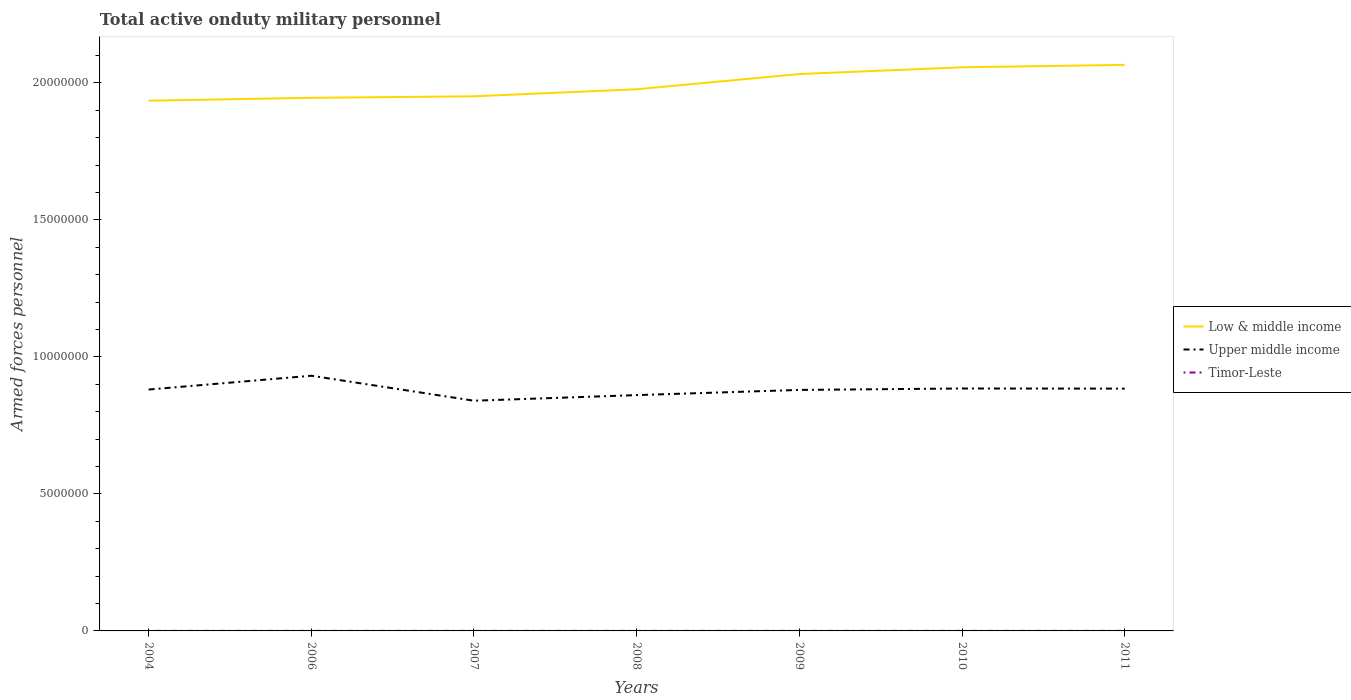Does the line corresponding to Timor-Leste intersect with the line corresponding to Low & middle income?
Give a very brief answer. No. Across all years, what is the maximum number of armed forces personnel in Timor-Leste?
Ensure brevity in your answer.  1000. What is the total number of armed forces personnel in Timor-Leste in the graph?
Ensure brevity in your answer.  -332. What is the difference between the highest and the second highest number of armed forces personnel in Timor-Leste?
Your response must be concise. 332. What is the difference between the highest and the lowest number of armed forces personnel in Upper middle income?
Provide a short and direct response. 4. Is the number of armed forces personnel in Upper middle income strictly greater than the number of armed forces personnel in Low & middle income over the years?
Make the answer very short. Yes. Are the values on the major ticks of Y-axis written in scientific E-notation?
Keep it short and to the point. No. Where does the legend appear in the graph?
Provide a short and direct response. Center right. How many legend labels are there?
Provide a succinct answer. 3. What is the title of the graph?
Keep it short and to the point. Total active onduty military personnel. What is the label or title of the X-axis?
Make the answer very short. Years. What is the label or title of the Y-axis?
Offer a very short reply. Armed forces personnel. What is the Armed forces personnel in Low & middle income in 2004?
Offer a very short reply. 1.94e+07. What is the Armed forces personnel of Upper middle income in 2004?
Provide a short and direct response. 8.81e+06. What is the Armed forces personnel in Timor-Leste in 2004?
Make the answer very short. 1000. What is the Armed forces personnel of Low & middle income in 2006?
Provide a succinct answer. 1.95e+07. What is the Armed forces personnel in Upper middle income in 2006?
Provide a short and direct response. 9.31e+06. What is the Armed forces personnel in Timor-Leste in 2006?
Your answer should be very brief. 1000. What is the Armed forces personnel in Low & middle income in 2007?
Keep it short and to the point. 1.95e+07. What is the Armed forces personnel of Upper middle income in 2007?
Offer a very short reply. 8.40e+06. What is the Armed forces personnel in Timor-Leste in 2007?
Your answer should be compact. 1000. What is the Armed forces personnel of Low & middle income in 2008?
Provide a succinct answer. 1.98e+07. What is the Armed forces personnel in Upper middle income in 2008?
Keep it short and to the point. 8.61e+06. What is the Armed forces personnel of Low & middle income in 2009?
Your answer should be compact. 2.03e+07. What is the Armed forces personnel of Upper middle income in 2009?
Offer a terse response. 8.80e+06. What is the Armed forces personnel of Timor-Leste in 2009?
Provide a succinct answer. 1332. What is the Armed forces personnel in Low & middle income in 2010?
Your answer should be very brief. 2.06e+07. What is the Armed forces personnel in Upper middle income in 2010?
Make the answer very short. 8.85e+06. What is the Armed forces personnel in Timor-Leste in 2010?
Provide a short and direct response. 1332. What is the Armed forces personnel in Low & middle income in 2011?
Give a very brief answer. 2.07e+07. What is the Armed forces personnel in Upper middle income in 2011?
Your answer should be compact. 8.84e+06. What is the Armed forces personnel of Timor-Leste in 2011?
Offer a terse response. 1330. Across all years, what is the maximum Armed forces personnel of Low & middle income?
Keep it short and to the point. 2.07e+07. Across all years, what is the maximum Armed forces personnel in Upper middle income?
Your answer should be very brief. 9.31e+06. Across all years, what is the maximum Armed forces personnel of Timor-Leste?
Keep it short and to the point. 1332. Across all years, what is the minimum Armed forces personnel of Low & middle income?
Provide a succinct answer. 1.94e+07. Across all years, what is the minimum Armed forces personnel in Upper middle income?
Make the answer very short. 8.40e+06. Across all years, what is the minimum Armed forces personnel of Timor-Leste?
Offer a very short reply. 1000. What is the total Armed forces personnel in Low & middle income in the graph?
Provide a succinct answer. 1.40e+08. What is the total Armed forces personnel in Upper middle income in the graph?
Give a very brief answer. 6.16e+07. What is the total Armed forces personnel in Timor-Leste in the graph?
Your answer should be compact. 7994. What is the difference between the Armed forces personnel of Low & middle income in 2004 and that in 2006?
Offer a very short reply. -1.04e+05. What is the difference between the Armed forces personnel in Upper middle income in 2004 and that in 2006?
Make the answer very short. -5.04e+05. What is the difference between the Armed forces personnel in Low & middle income in 2004 and that in 2007?
Ensure brevity in your answer.  -1.60e+05. What is the difference between the Armed forces personnel of Upper middle income in 2004 and that in 2007?
Your answer should be very brief. 4.08e+05. What is the difference between the Armed forces personnel of Timor-Leste in 2004 and that in 2007?
Provide a succinct answer. 0. What is the difference between the Armed forces personnel of Low & middle income in 2004 and that in 2008?
Offer a very short reply. -4.17e+05. What is the difference between the Armed forces personnel of Upper middle income in 2004 and that in 2008?
Your answer should be compact. 2.03e+05. What is the difference between the Armed forces personnel in Low & middle income in 2004 and that in 2009?
Give a very brief answer. -9.72e+05. What is the difference between the Armed forces personnel in Upper middle income in 2004 and that in 2009?
Offer a terse response. 1.35e+04. What is the difference between the Armed forces personnel in Timor-Leste in 2004 and that in 2009?
Keep it short and to the point. -332. What is the difference between the Armed forces personnel of Low & middle income in 2004 and that in 2010?
Give a very brief answer. -1.22e+06. What is the difference between the Armed forces personnel in Upper middle income in 2004 and that in 2010?
Offer a terse response. -3.85e+04. What is the difference between the Armed forces personnel of Timor-Leste in 2004 and that in 2010?
Your answer should be very brief. -332. What is the difference between the Armed forces personnel of Low & middle income in 2004 and that in 2011?
Provide a short and direct response. -1.31e+06. What is the difference between the Armed forces personnel in Upper middle income in 2004 and that in 2011?
Your answer should be very brief. -3.43e+04. What is the difference between the Armed forces personnel in Timor-Leste in 2004 and that in 2011?
Keep it short and to the point. -330. What is the difference between the Armed forces personnel of Low & middle income in 2006 and that in 2007?
Offer a terse response. -5.58e+04. What is the difference between the Armed forces personnel of Upper middle income in 2006 and that in 2007?
Offer a very short reply. 9.12e+05. What is the difference between the Armed forces personnel in Low & middle income in 2006 and that in 2008?
Provide a short and direct response. -3.13e+05. What is the difference between the Armed forces personnel of Upper middle income in 2006 and that in 2008?
Offer a terse response. 7.07e+05. What is the difference between the Armed forces personnel of Low & middle income in 2006 and that in 2009?
Provide a succinct answer. -8.68e+05. What is the difference between the Armed forces personnel in Upper middle income in 2006 and that in 2009?
Ensure brevity in your answer.  5.18e+05. What is the difference between the Armed forces personnel in Timor-Leste in 2006 and that in 2009?
Make the answer very short. -332. What is the difference between the Armed forces personnel in Low & middle income in 2006 and that in 2010?
Provide a short and direct response. -1.11e+06. What is the difference between the Armed forces personnel in Upper middle income in 2006 and that in 2010?
Provide a succinct answer. 4.66e+05. What is the difference between the Armed forces personnel of Timor-Leste in 2006 and that in 2010?
Ensure brevity in your answer.  -332. What is the difference between the Armed forces personnel of Low & middle income in 2006 and that in 2011?
Keep it short and to the point. -1.20e+06. What is the difference between the Armed forces personnel in Upper middle income in 2006 and that in 2011?
Offer a very short reply. 4.70e+05. What is the difference between the Armed forces personnel of Timor-Leste in 2006 and that in 2011?
Your answer should be very brief. -330. What is the difference between the Armed forces personnel in Low & middle income in 2007 and that in 2008?
Offer a very short reply. -2.57e+05. What is the difference between the Armed forces personnel in Upper middle income in 2007 and that in 2008?
Offer a very short reply. -2.05e+05. What is the difference between the Armed forces personnel in Timor-Leste in 2007 and that in 2008?
Offer a terse response. 0. What is the difference between the Armed forces personnel of Low & middle income in 2007 and that in 2009?
Give a very brief answer. -8.12e+05. What is the difference between the Armed forces personnel of Upper middle income in 2007 and that in 2009?
Your response must be concise. -3.94e+05. What is the difference between the Armed forces personnel in Timor-Leste in 2007 and that in 2009?
Keep it short and to the point. -332. What is the difference between the Armed forces personnel in Low & middle income in 2007 and that in 2010?
Your answer should be very brief. -1.06e+06. What is the difference between the Armed forces personnel of Upper middle income in 2007 and that in 2010?
Provide a short and direct response. -4.46e+05. What is the difference between the Armed forces personnel of Timor-Leste in 2007 and that in 2010?
Provide a short and direct response. -332. What is the difference between the Armed forces personnel in Low & middle income in 2007 and that in 2011?
Your answer should be very brief. -1.15e+06. What is the difference between the Armed forces personnel of Upper middle income in 2007 and that in 2011?
Offer a terse response. -4.42e+05. What is the difference between the Armed forces personnel in Timor-Leste in 2007 and that in 2011?
Your answer should be compact. -330. What is the difference between the Armed forces personnel in Low & middle income in 2008 and that in 2009?
Keep it short and to the point. -5.55e+05. What is the difference between the Armed forces personnel in Upper middle income in 2008 and that in 2009?
Give a very brief answer. -1.89e+05. What is the difference between the Armed forces personnel of Timor-Leste in 2008 and that in 2009?
Your response must be concise. -332. What is the difference between the Armed forces personnel in Low & middle income in 2008 and that in 2010?
Your response must be concise. -8.02e+05. What is the difference between the Armed forces personnel in Upper middle income in 2008 and that in 2010?
Provide a short and direct response. -2.41e+05. What is the difference between the Armed forces personnel in Timor-Leste in 2008 and that in 2010?
Make the answer very short. -332. What is the difference between the Armed forces personnel of Low & middle income in 2008 and that in 2011?
Keep it short and to the point. -8.90e+05. What is the difference between the Armed forces personnel in Upper middle income in 2008 and that in 2011?
Make the answer very short. -2.37e+05. What is the difference between the Armed forces personnel of Timor-Leste in 2008 and that in 2011?
Keep it short and to the point. -330. What is the difference between the Armed forces personnel of Low & middle income in 2009 and that in 2010?
Ensure brevity in your answer.  -2.46e+05. What is the difference between the Armed forces personnel in Upper middle income in 2009 and that in 2010?
Make the answer very short. -5.20e+04. What is the difference between the Armed forces personnel in Low & middle income in 2009 and that in 2011?
Your answer should be very brief. -3.35e+05. What is the difference between the Armed forces personnel in Upper middle income in 2009 and that in 2011?
Give a very brief answer. -4.79e+04. What is the difference between the Armed forces personnel in Low & middle income in 2010 and that in 2011?
Keep it short and to the point. -8.85e+04. What is the difference between the Armed forces personnel in Upper middle income in 2010 and that in 2011?
Provide a short and direct response. 4131. What is the difference between the Armed forces personnel in Timor-Leste in 2010 and that in 2011?
Offer a very short reply. 2. What is the difference between the Armed forces personnel in Low & middle income in 2004 and the Armed forces personnel in Upper middle income in 2006?
Your response must be concise. 1.00e+07. What is the difference between the Armed forces personnel in Low & middle income in 2004 and the Armed forces personnel in Timor-Leste in 2006?
Your answer should be very brief. 1.94e+07. What is the difference between the Armed forces personnel of Upper middle income in 2004 and the Armed forces personnel of Timor-Leste in 2006?
Your response must be concise. 8.81e+06. What is the difference between the Armed forces personnel of Low & middle income in 2004 and the Armed forces personnel of Upper middle income in 2007?
Your response must be concise. 1.10e+07. What is the difference between the Armed forces personnel in Low & middle income in 2004 and the Armed forces personnel in Timor-Leste in 2007?
Your answer should be very brief. 1.94e+07. What is the difference between the Armed forces personnel in Upper middle income in 2004 and the Armed forces personnel in Timor-Leste in 2007?
Keep it short and to the point. 8.81e+06. What is the difference between the Armed forces personnel in Low & middle income in 2004 and the Armed forces personnel in Upper middle income in 2008?
Make the answer very short. 1.07e+07. What is the difference between the Armed forces personnel of Low & middle income in 2004 and the Armed forces personnel of Timor-Leste in 2008?
Ensure brevity in your answer.  1.94e+07. What is the difference between the Armed forces personnel of Upper middle income in 2004 and the Armed forces personnel of Timor-Leste in 2008?
Offer a very short reply. 8.81e+06. What is the difference between the Armed forces personnel in Low & middle income in 2004 and the Armed forces personnel in Upper middle income in 2009?
Give a very brief answer. 1.06e+07. What is the difference between the Armed forces personnel in Low & middle income in 2004 and the Armed forces personnel in Timor-Leste in 2009?
Provide a succinct answer. 1.94e+07. What is the difference between the Armed forces personnel of Upper middle income in 2004 and the Armed forces personnel of Timor-Leste in 2009?
Ensure brevity in your answer.  8.81e+06. What is the difference between the Armed forces personnel in Low & middle income in 2004 and the Armed forces personnel in Upper middle income in 2010?
Provide a short and direct response. 1.05e+07. What is the difference between the Armed forces personnel in Low & middle income in 2004 and the Armed forces personnel in Timor-Leste in 2010?
Your answer should be compact. 1.94e+07. What is the difference between the Armed forces personnel in Upper middle income in 2004 and the Armed forces personnel in Timor-Leste in 2010?
Offer a very short reply. 8.81e+06. What is the difference between the Armed forces personnel of Low & middle income in 2004 and the Armed forces personnel of Upper middle income in 2011?
Give a very brief answer. 1.05e+07. What is the difference between the Armed forces personnel of Low & middle income in 2004 and the Armed forces personnel of Timor-Leste in 2011?
Provide a succinct answer. 1.94e+07. What is the difference between the Armed forces personnel in Upper middle income in 2004 and the Armed forces personnel in Timor-Leste in 2011?
Keep it short and to the point. 8.81e+06. What is the difference between the Armed forces personnel in Low & middle income in 2006 and the Armed forces personnel in Upper middle income in 2007?
Keep it short and to the point. 1.11e+07. What is the difference between the Armed forces personnel of Low & middle income in 2006 and the Armed forces personnel of Timor-Leste in 2007?
Keep it short and to the point. 1.95e+07. What is the difference between the Armed forces personnel in Upper middle income in 2006 and the Armed forces personnel in Timor-Leste in 2007?
Make the answer very short. 9.31e+06. What is the difference between the Armed forces personnel in Low & middle income in 2006 and the Armed forces personnel in Upper middle income in 2008?
Keep it short and to the point. 1.09e+07. What is the difference between the Armed forces personnel in Low & middle income in 2006 and the Armed forces personnel in Timor-Leste in 2008?
Give a very brief answer. 1.95e+07. What is the difference between the Armed forces personnel in Upper middle income in 2006 and the Armed forces personnel in Timor-Leste in 2008?
Your response must be concise. 9.31e+06. What is the difference between the Armed forces personnel of Low & middle income in 2006 and the Armed forces personnel of Upper middle income in 2009?
Offer a very short reply. 1.07e+07. What is the difference between the Armed forces personnel in Low & middle income in 2006 and the Armed forces personnel in Timor-Leste in 2009?
Make the answer very short. 1.95e+07. What is the difference between the Armed forces personnel of Upper middle income in 2006 and the Armed forces personnel of Timor-Leste in 2009?
Make the answer very short. 9.31e+06. What is the difference between the Armed forces personnel of Low & middle income in 2006 and the Armed forces personnel of Upper middle income in 2010?
Your response must be concise. 1.06e+07. What is the difference between the Armed forces personnel of Low & middle income in 2006 and the Armed forces personnel of Timor-Leste in 2010?
Your answer should be compact. 1.95e+07. What is the difference between the Armed forces personnel of Upper middle income in 2006 and the Armed forces personnel of Timor-Leste in 2010?
Your answer should be very brief. 9.31e+06. What is the difference between the Armed forces personnel of Low & middle income in 2006 and the Armed forces personnel of Upper middle income in 2011?
Your answer should be very brief. 1.06e+07. What is the difference between the Armed forces personnel in Low & middle income in 2006 and the Armed forces personnel in Timor-Leste in 2011?
Make the answer very short. 1.95e+07. What is the difference between the Armed forces personnel of Upper middle income in 2006 and the Armed forces personnel of Timor-Leste in 2011?
Keep it short and to the point. 9.31e+06. What is the difference between the Armed forces personnel in Low & middle income in 2007 and the Armed forces personnel in Upper middle income in 2008?
Your response must be concise. 1.09e+07. What is the difference between the Armed forces personnel in Low & middle income in 2007 and the Armed forces personnel in Timor-Leste in 2008?
Ensure brevity in your answer.  1.95e+07. What is the difference between the Armed forces personnel in Upper middle income in 2007 and the Armed forces personnel in Timor-Leste in 2008?
Provide a succinct answer. 8.40e+06. What is the difference between the Armed forces personnel of Low & middle income in 2007 and the Armed forces personnel of Upper middle income in 2009?
Ensure brevity in your answer.  1.07e+07. What is the difference between the Armed forces personnel in Low & middle income in 2007 and the Armed forces personnel in Timor-Leste in 2009?
Give a very brief answer. 1.95e+07. What is the difference between the Armed forces personnel in Upper middle income in 2007 and the Armed forces personnel in Timor-Leste in 2009?
Your answer should be compact. 8.40e+06. What is the difference between the Armed forces personnel in Low & middle income in 2007 and the Armed forces personnel in Upper middle income in 2010?
Give a very brief answer. 1.07e+07. What is the difference between the Armed forces personnel of Low & middle income in 2007 and the Armed forces personnel of Timor-Leste in 2010?
Make the answer very short. 1.95e+07. What is the difference between the Armed forces personnel of Upper middle income in 2007 and the Armed forces personnel of Timor-Leste in 2010?
Your response must be concise. 8.40e+06. What is the difference between the Armed forces personnel of Low & middle income in 2007 and the Armed forces personnel of Upper middle income in 2011?
Your answer should be compact. 1.07e+07. What is the difference between the Armed forces personnel in Low & middle income in 2007 and the Armed forces personnel in Timor-Leste in 2011?
Offer a terse response. 1.95e+07. What is the difference between the Armed forces personnel in Upper middle income in 2007 and the Armed forces personnel in Timor-Leste in 2011?
Offer a terse response. 8.40e+06. What is the difference between the Armed forces personnel of Low & middle income in 2008 and the Armed forces personnel of Upper middle income in 2009?
Make the answer very short. 1.10e+07. What is the difference between the Armed forces personnel of Low & middle income in 2008 and the Armed forces personnel of Timor-Leste in 2009?
Offer a very short reply. 1.98e+07. What is the difference between the Armed forces personnel in Upper middle income in 2008 and the Armed forces personnel in Timor-Leste in 2009?
Provide a short and direct response. 8.61e+06. What is the difference between the Armed forces personnel of Low & middle income in 2008 and the Armed forces personnel of Upper middle income in 2010?
Offer a terse response. 1.09e+07. What is the difference between the Armed forces personnel in Low & middle income in 2008 and the Armed forces personnel in Timor-Leste in 2010?
Keep it short and to the point. 1.98e+07. What is the difference between the Armed forces personnel in Upper middle income in 2008 and the Armed forces personnel in Timor-Leste in 2010?
Keep it short and to the point. 8.61e+06. What is the difference between the Armed forces personnel of Low & middle income in 2008 and the Armed forces personnel of Upper middle income in 2011?
Your answer should be very brief. 1.09e+07. What is the difference between the Armed forces personnel in Low & middle income in 2008 and the Armed forces personnel in Timor-Leste in 2011?
Keep it short and to the point. 1.98e+07. What is the difference between the Armed forces personnel in Upper middle income in 2008 and the Armed forces personnel in Timor-Leste in 2011?
Your response must be concise. 8.61e+06. What is the difference between the Armed forces personnel of Low & middle income in 2009 and the Armed forces personnel of Upper middle income in 2010?
Keep it short and to the point. 1.15e+07. What is the difference between the Armed forces personnel in Low & middle income in 2009 and the Armed forces personnel in Timor-Leste in 2010?
Your answer should be very brief. 2.03e+07. What is the difference between the Armed forces personnel of Upper middle income in 2009 and the Armed forces personnel of Timor-Leste in 2010?
Provide a short and direct response. 8.79e+06. What is the difference between the Armed forces personnel in Low & middle income in 2009 and the Armed forces personnel in Upper middle income in 2011?
Ensure brevity in your answer.  1.15e+07. What is the difference between the Armed forces personnel in Low & middle income in 2009 and the Armed forces personnel in Timor-Leste in 2011?
Provide a succinct answer. 2.03e+07. What is the difference between the Armed forces personnel of Upper middle income in 2009 and the Armed forces personnel of Timor-Leste in 2011?
Offer a terse response. 8.79e+06. What is the difference between the Armed forces personnel in Low & middle income in 2010 and the Armed forces personnel in Upper middle income in 2011?
Provide a short and direct response. 1.17e+07. What is the difference between the Armed forces personnel in Low & middle income in 2010 and the Armed forces personnel in Timor-Leste in 2011?
Keep it short and to the point. 2.06e+07. What is the difference between the Armed forces personnel in Upper middle income in 2010 and the Armed forces personnel in Timor-Leste in 2011?
Offer a very short reply. 8.85e+06. What is the average Armed forces personnel in Low & middle income per year?
Provide a succinct answer. 1.99e+07. What is the average Armed forces personnel in Upper middle income per year?
Ensure brevity in your answer.  8.80e+06. What is the average Armed forces personnel in Timor-Leste per year?
Make the answer very short. 1142. In the year 2004, what is the difference between the Armed forces personnel in Low & middle income and Armed forces personnel in Upper middle income?
Your answer should be very brief. 1.05e+07. In the year 2004, what is the difference between the Armed forces personnel of Low & middle income and Armed forces personnel of Timor-Leste?
Give a very brief answer. 1.94e+07. In the year 2004, what is the difference between the Armed forces personnel in Upper middle income and Armed forces personnel in Timor-Leste?
Your response must be concise. 8.81e+06. In the year 2006, what is the difference between the Armed forces personnel in Low & middle income and Armed forces personnel in Upper middle income?
Your response must be concise. 1.01e+07. In the year 2006, what is the difference between the Armed forces personnel of Low & middle income and Armed forces personnel of Timor-Leste?
Your response must be concise. 1.95e+07. In the year 2006, what is the difference between the Armed forces personnel in Upper middle income and Armed forces personnel in Timor-Leste?
Keep it short and to the point. 9.31e+06. In the year 2007, what is the difference between the Armed forces personnel in Low & middle income and Armed forces personnel in Upper middle income?
Provide a succinct answer. 1.11e+07. In the year 2007, what is the difference between the Armed forces personnel of Low & middle income and Armed forces personnel of Timor-Leste?
Provide a succinct answer. 1.95e+07. In the year 2007, what is the difference between the Armed forces personnel in Upper middle income and Armed forces personnel in Timor-Leste?
Provide a short and direct response. 8.40e+06. In the year 2008, what is the difference between the Armed forces personnel of Low & middle income and Armed forces personnel of Upper middle income?
Provide a succinct answer. 1.12e+07. In the year 2008, what is the difference between the Armed forces personnel in Low & middle income and Armed forces personnel in Timor-Leste?
Make the answer very short. 1.98e+07. In the year 2008, what is the difference between the Armed forces personnel in Upper middle income and Armed forces personnel in Timor-Leste?
Keep it short and to the point. 8.61e+06. In the year 2009, what is the difference between the Armed forces personnel in Low & middle income and Armed forces personnel in Upper middle income?
Your answer should be very brief. 1.15e+07. In the year 2009, what is the difference between the Armed forces personnel of Low & middle income and Armed forces personnel of Timor-Leste?
Offer a very short reply. 2.03e+07. In the year 2009, what is the difference between the Armed forces personnel of Upper middle income and Armed forces personnel of Timor-Leste?
Keep it short and to the point. 8.79e+06. In the year 2010, what is the difference between the Armed forces personnel of Low & middle income and Armed forces personnel of Upper middle income?
Keep it short and to the point. 1.17e+07. In the year 2010, what is the difference between the Armed forces personnel in Low & middle income and Armed forces personnel in Timor-Leste?
Your answer should be compact. 2.06e+07. In the year 2010, what is the difference between the Armed forces personnel in Upper middle income and Armed forces personnel in Timor-Leste?
Your response must be concise. 8.85e+06. In the year 2011, what is the difference between the Armed forces personnel of Low & middle income and Armed forces personnel of Upper middle income?
Offer a terse response. 1.18e+07. In the year 2011, what is the difference between the Armed forces personnel in Low & middle income and Armed forces personnel in Timor-Leste?
Provide a succinct answer. 2.07e+07. In the year 2011, what is the difference between the Armed forces personnel of Upper middle income and Armed forces personnel of Timor-Leste?
Your response must be concise. 8.84e+06. What is the ratio of the Armed forces personnel in Upper middle income in 2004 to that in 2006?
Ensure brevity in your answer.  0.95. What is the ratio of the Armed forces personnel of Upper middle income in 2004 to that in 2007?
Make the answer very short. 1.05. What is the ratio of the Armed forces personnel of Timor-Leste in 2004 to that in 2007?
Your answer should be very brief. 1. What is the ratio of the Armed forces personnel in Low & middle income in 2004 to that in 2008?
Keep it short and to the point. 0.98. What is the ratio of the Armed forces personnel in Upper middle income in 2004 to that in 2008?
Give a very brief answer. 1.02. What is the ratio of the Armed forces personnel of Low & middle income in 2004 to that in 2009?
Make the answer very short. 0.95. What is the ratio of the Armed forces personnel in Timor-Leste in 2004 to that in 2009?
Ensure brevity in your answer.  0.75. What is the ratio of the Armed forces personnel in Low & middle income in 2004 to that in 2010?
Ensure brevity in your answer.  0.94. What is the ratio of the Armed forces personnel of Upper middle income in 2004 to that in 2010?
Your response must be concise. 1. What is the ratio of the Armed forces personnel of Timor-Leste in 2004 to that in 2010?
Your answer should be compact. 0.75. What is the ratio of the Armed forces personnel in Low & middle income in 2004 to that in 2011?
Offer a terse response. 0.94. What is the ratio of the Armed forces personnel in Upper middle income in 2004 to that in 2011?
Offer a terse response. 1. What is the ratio of the Armed forces personnel of Timor-Leste in 2004 to that in 2011?
Offer a very short reply. 0.75. What is the ratio of the Armed forces personnel in Upper middle income in 2006 to that in 2007?
Your response must be concise. 1.11. What is the ratio of the Armed forces personnel in Timor-Leste in 2006 to that in 2007?
Make the answer very short. 1. What is the ratio of the Armed forces personnel of Low & middle income in 2006 to that in 2008?
Your response must be concise. 0.98. What is the ratio of the Armed forces personnel of Upper middle income in 2006 to that in 2008?
Make the answer very short. 1.08. What is the ratio of the Armed forces personnel of Timor-Leste in 2006 to that in 2008?
Provide a short and direct response. 1. What is the ratio of the Armed forces personnel of Low & middle income in 2006 to that in 2009?
Your response must be concise. 0.96. What is the ratio of the Armed forces personnel in Upper middle income in 2006 to that in 2009?
Provide a succinct answer. 1.06. What is the ratio of the Armed forces personnel in Timor-Leste in 2006 to that in 2009?
Make the answer very short. 0.75. What is the ratio of the Armed forces personnel of Low & middle income in 2006 to that in 2010?
Ensure brevity in your answer.  0.95. What is the ratio of the Armed forces personnel in Upper middle income in 2006 to that in 2010?
Give a very brief answer. 1.05. What is the ratio of the Armed forces personnel in Timor-Leste in 2006 to that in 2010?
Your response must be concise. 0.75. What is the ratio of the Armed forces personnel of Low & middle income in 2006 to that in 2011?
Your answer should be compact. 0.94. What is the ratio of the Armed forces personnel of Upper middle income in 2006 to that in 2011?
Provide a short and direct response. 1.05. What is the ratio of the Armed forces personnel in Timor-Leste in 2006 to that in 2011?
Keep it short and to the point. 0.75. What is the ratio of the Armed forces personnel of Low & middle income in 2007 to that in 2008?
Give a very brief answer. 0.99. What is the ratio of the Armed forces personnel in Upper middle income in 2007 to that in 2008?
Keep it short and to the point. 0.98. What is the ratio of the Armed forces personnel in Timor-Leste in 2007 to that in 2008?
Your answer should be compact. 1. What is the ratio of the Armed forces personnel of Upper middle income in 2007 to that in 2009?
Ensure brevity in your answer.  0.96. What is the ratio of the Armed forces personnel in Timor-Leste in 2007 to that in 2009?
Provide a succinct answer. 0.75. What is the ratio of the Armed forces personnel of Low & middle income in 2007 to that in 2010?
Make the answer very short. 0.95. What is the ratio of the Armed forces personnel of Upper middle income in 2007 to that in 2010?
Keep it short and to the point. 0.95. What is the ratio of the Armed forces personnel in Timor-Leste in 2007 to that in 2010?
Offer a terse response. 0.75. What is the ratio of the Armed forces personnel in Low & middle income in 2007 to that in 2011?
Provide a succinct answer. 0.94. What is the ratio of the Armed forces personnel in Upper middle income in 2007 to that in 2011?
Give a very brief answer. 0.95. What is the ratio of the Armed forces personnel in Timor-Leste in 2007 to that in 2011?
Offer a very short reply. 0.75. What is the ratio of the Armed forces personnel of Low & middle income in 2008 to that in 2009?
Keep it short and to the point. 0.97. What is the ratio of the Armed forces personnel in Upper middle income in 2008 to that in 2009?
Make the answer very short. 0.98. What is the ratio of the Armed forces personnel in Timor-Leste in 2008 to that in 2009?
Make the answer very short. 0.75. What is the ratio of the Armed forces personnel in Low & middle income in 2008 to that in 2010?
Keep it short and to the point. 0.96. What is the ratio of the Armed forces personnel in Upper middle income in 2008 to that in 2010?
Keep it short and to the point. 0.97. What is the ratio of the Armed forces personnel of Timor-Leste in 2008 to that in 2010?
Your answer should be compact. 0.75. What is the ratio of the Armed forces personnel in Low & middle income in 2008 to that in 2011?
Your response must be concise. 0.96. What is the ratio of the Armed forces personnel of Upper middle income in 2008 to that in 2011?
Your response must be concise. 0.97. What is the ratio of the Armed forces personnel of Timor-Leste in 2008 to that in 2011?
Offer a very short reply. 0.75. What is the ratio of the Armed forces personnel in Low & middle income in 2009 to that in 2011?
Make the answer very short. 0.98. What is the ratio of the Armed forces personnel in Upper middle income in 2010 to that in 2011?
Keep it short and to the point. 1. What is the difference between the highest and the second highest Armed forces personnel of Low & middle income?
Offer a very short reply. 8.85e+04. What is the difference between the highest and the second highest Armed forces personnel in Upper middle income?
Your answer should be compact. 4.66e+05. What is the difference between the highest and the second highest Armed forces personnel of Timor-Leste?
Provide a succinct answer. 0. What is the difference between the highest and the lowest Armed forces personnel of Low & middle income?
Offer a very short reply. 1.31e+06. What is the difference between the highest and the lowest Armed forces personnel in Upper middle income?
Your answer should be very brief. 9.12e+05. What is the difference between the highest and the lowest Armed forces personnel in Timor-Leste?
Your answer should be compact. 332. 